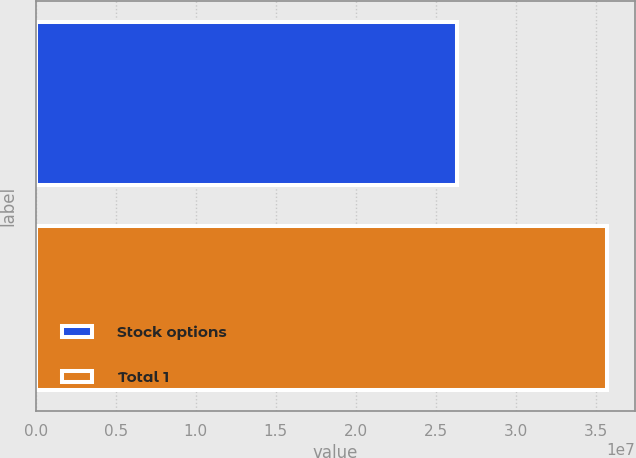Convert chart. <chart><loc_0><loc_0><loc_500><loc_500><bar_chart><fcel>Stock options<fcel>Total 1<nl><fcel>2.63364e+07<fcel>3.56861e+07<nl></chart> 